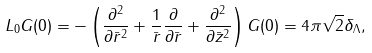<formula> <loc_0><loc_0><loc_500><loc_500>{ } L _ { 0 } G ( 0 ) = - \left ( \frac { \partial ^ { 2 } } { \partial \bar { r } ^ { 2 } } + \frac { 1 } { \bar { r } } \frac { \partial } { \partial \bar { r } } + \frac { \partial ^ { 2 } } { \partial \bar { z } ^ { 2 } } \right ) G ( 0 ) = 4 \pi \sqrt { 2 } \delta _ { \Lambda } ,</formula> 